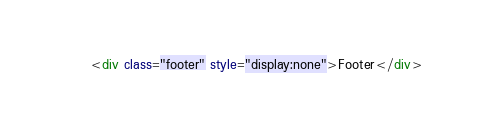<code> <loc_0><loc_0><loc_500><loc_500><_HTML_><div class="footer" style="display:none">Footer</div>
</code> 